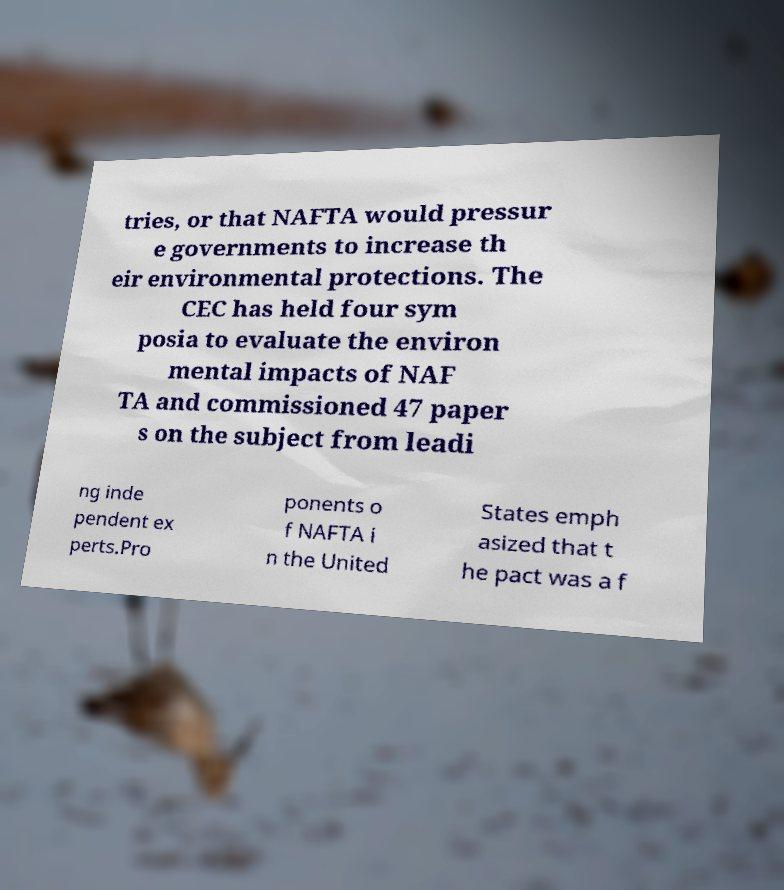Please identify and transcribe the text found in this image. tries, or that NAFTA would pressur e governments to increase th eir environmental protections. The CEC has held four sym posia to evaluate the environ mental impacts of NAF TA and commissioned 47 paper s on the subject from leadi ng inde pendent ex perts.Pro ponents o f NAFTA i n the United States emph asized that t he pact was a f 